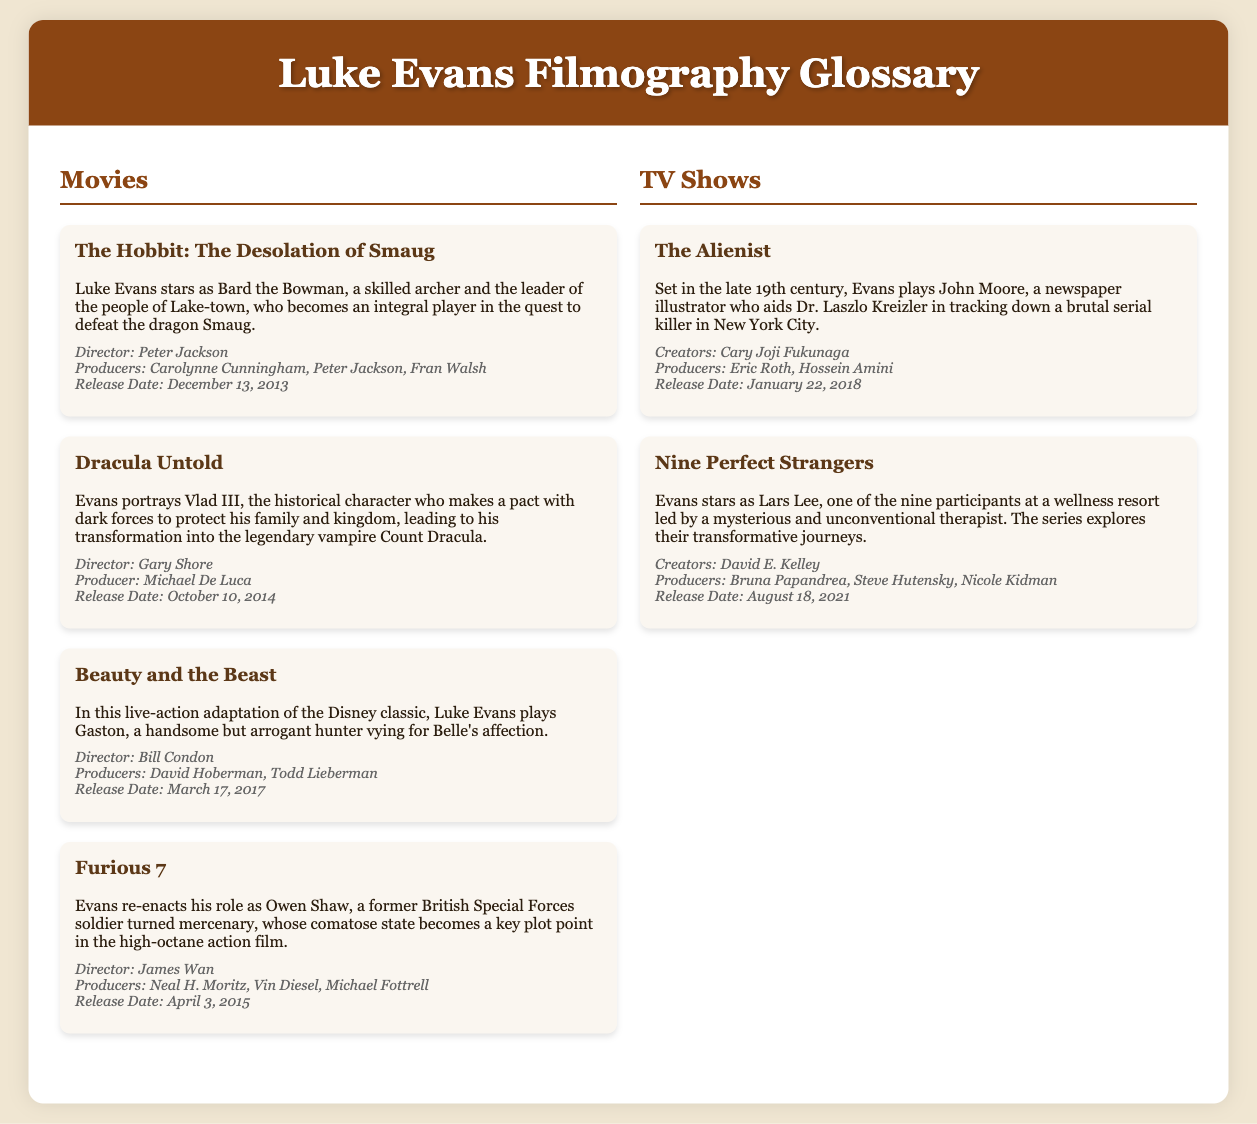What role does Luke Evans play in The Hobbit: The Desolation of Smaug? The document states that Luke Evans stars as Bard the Bowman in The Hobbit: The Desolation of Smaug.
Answer: Bard the Bowman Who directed Dracula Untold? According to the production details in the document, Gary Shore is the director of Dracula Untold.
Answer: Gary Shore What is the release date of Beauty and the Beast? The document lists March 17, 2017 as the release date for Beauty and the Beast.
Answer: March 17, 2017 Which character does Luke Evans portray in the TV show The Alienist? The noted character in the document that Luke Evans plays in The Alienist is John Moore.
Answer: John Moore How many participants are in Nine Perfect Strangers? Based on the document, there are nine participants in Nine Perfect Strangers.
Answer: Nine What is the profession of Luke Evans' character in The Alienist? The document describes John Moore as a newspaper illustrator in The Alienist.
Answer: Newspaper illustrator In which movie does Luke Evans reprise his role as Owen Shaw? The document mentions that Luke Evans re-enacts his role as Owen Shaw in Furious 7.
Answer: Furious 7 Who produced The Alienist? The document states Eric Roth and Hossein Amini as producers of The Alienist.
Answer: Eric Roth, Hossein Amini 